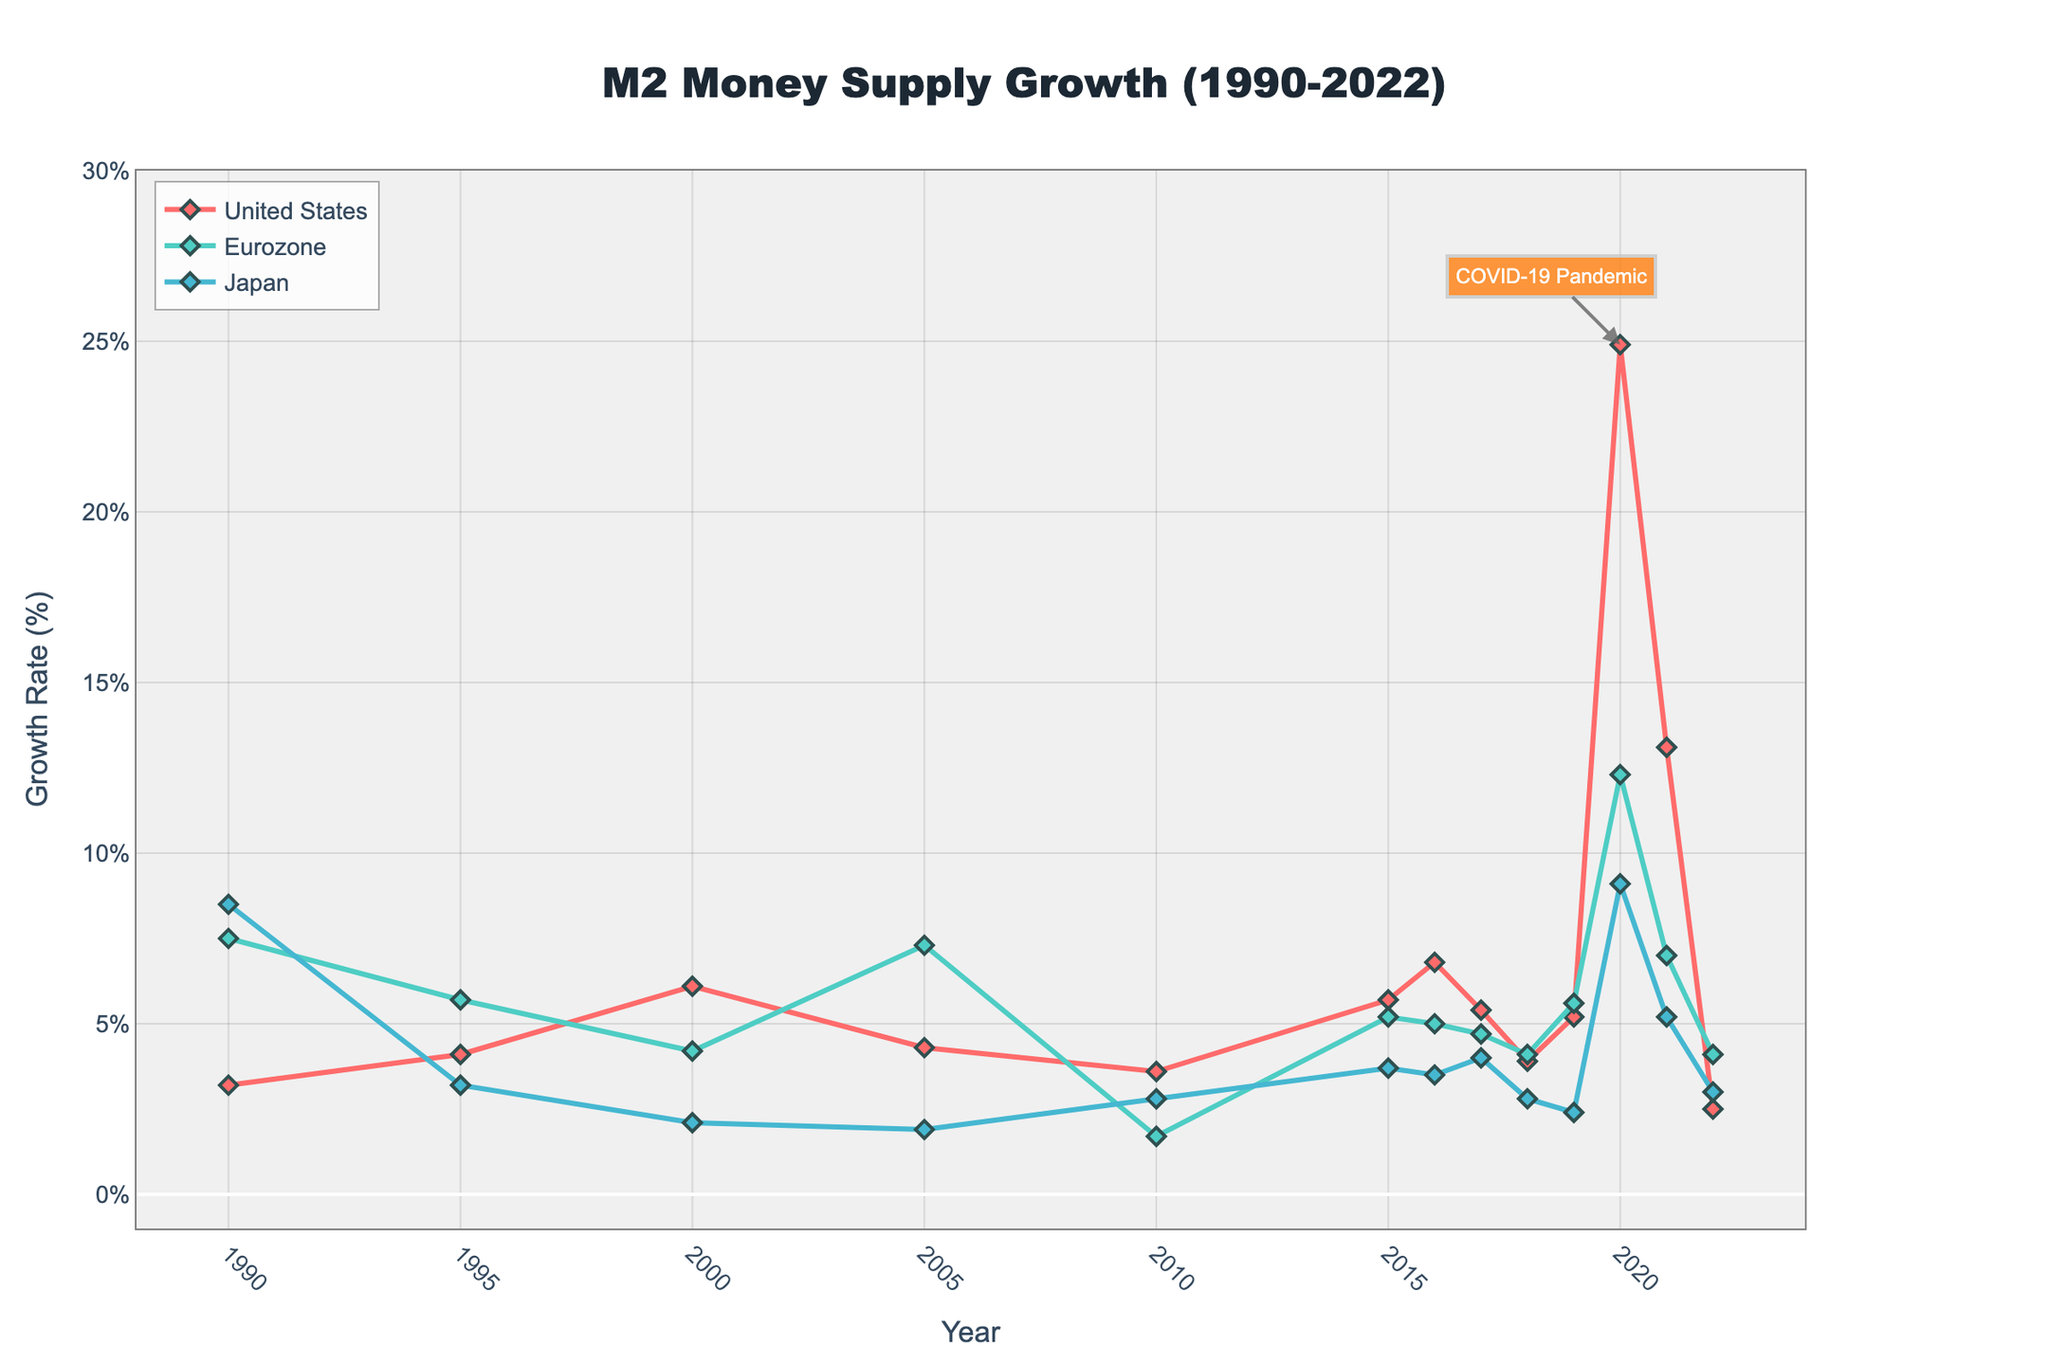What is the general trend of the M2 money supply growth rate in the United States from 1990 to 2022? The line for the United States shows varying growth rates with notable peaks and troughs. The most significant peak occurs in 2020, reaching 24.9%, followed by a steep decline in subsequent years. Before 2020, growth rates fluctuated between around 2.5% and 6.8%.
Answer: Fluctuating with a significant peak in 2020 During which year did all three regions (US, Eurozone, Japan) see an increase in their M2 money supply growth rates compared to the previous year? By observing the lines for each region, only in 2020, all three regions exhibit a noticeable increase in their growth rates compared to 2019.
Answer: 2020 Which region had the highest M2 money supply growth rate in 2005, and what was the value? By comparing the data points for 2005, the Eurozone had the highest growth rate, as the green-colored line is at the peak. The value is 7.3%.
Answer: Eurozone, 7.3% How does the M2 money supply growth rate in the United States in 2022 compare to that of Japan in the same year? By looking at the values for 2022, the United States has a growth rate of 2.5%, while Japan's growth rate is 3.0%. Therefore, Japan's growth rate is higher.
Answer: Japan's growth rate is higher What was the difference in the US M2 money supply growth rate between 2020 and 2021? Observing the points for the US in 2020 and 2021, the growth rates are 24.9% and 13.1%, respectively. The difference is calculated as 24.9% - 13.1% = 11.8%.
Answer: 11.8% Which country experienced the smallest fluctuation in M2 money supply growth rates from 1990 to 2019, and what indicates this? By analyzing the smoothness and variation in the lines from 1990 to 2019, Japan's line appears to exhibit the smallest fluctuation, maintaining more consistent, lower values compared to the US and Eurozone.
Answer: Japan What key event is annotated in the plot, and how did it impact the US M2 money supply growth rate? The annotation points to the COVID-19 Pandemic in 2020 and its impact on the US growth rate, which spiked significantly to 24.9%.
Answer: COVID-19 Pandemic; significant spike Considering the data points from 1990 to 2022, what is the average M2 money supply growth rate for the Eurozone? Sum of the Eurozone's growth rates for all the years provided: (7.5 + 5.7 + 4.2 + 7.3 + 1.7 + 5.2 + 5.0 + 4.7 + 4.1 + 5.6 + 12.3 + 7.0 + 4.1) = 74.4. Divide by the number of years (13): 74.4 / 13 ≈ 5.72%.
Answer: 5.72% 